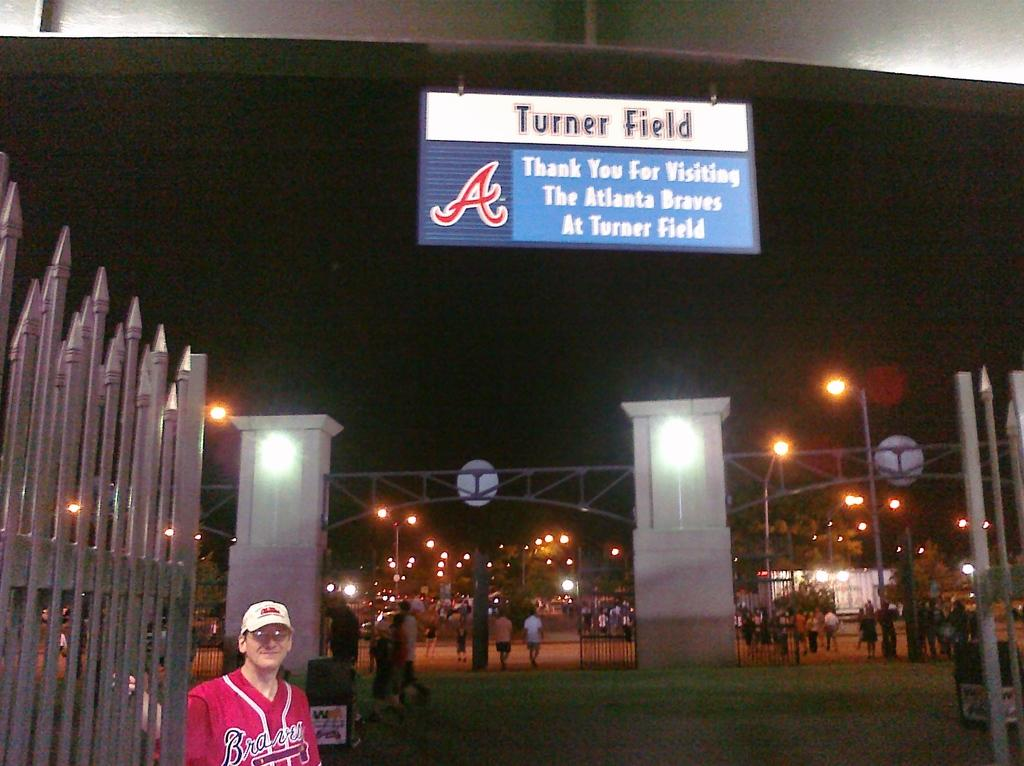Provide a one-sentence caption for the provided image. Man taking a picture under a sign that says Turner Field. 